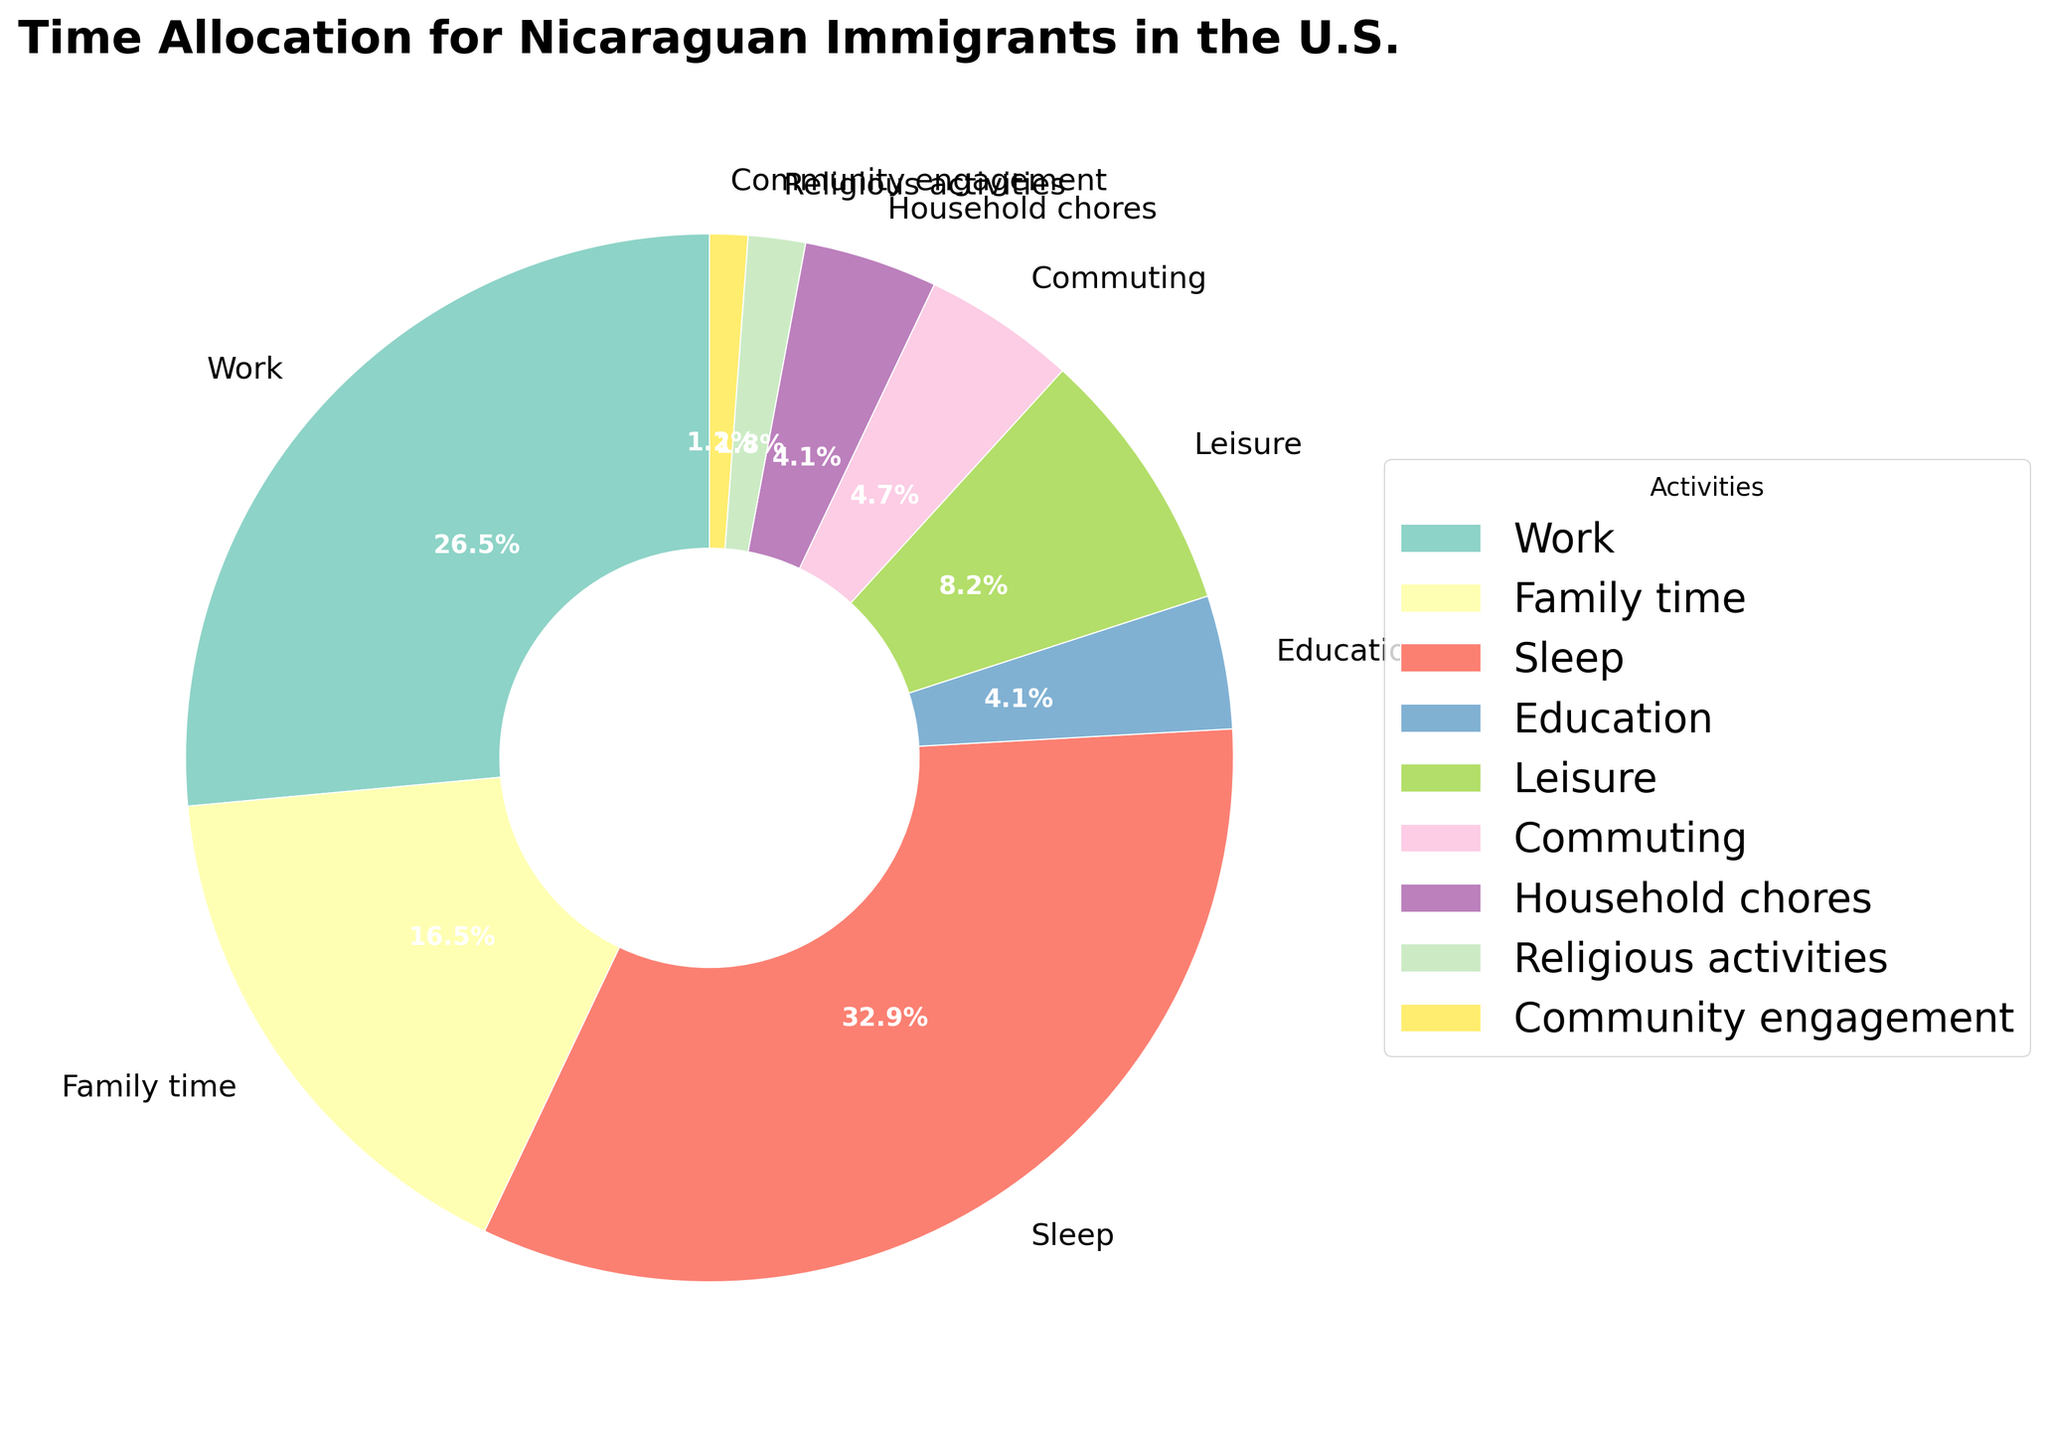What's the most time-consuming activity? The pie chart shows varying percentages for each activity, with the largest segment representing the highest time allocation. Identifying the largest segment of the pie, we see that "Sleep" is the most time-consuming.
Answer: Sleep What is the combined percentage of time spent on education and leisure? To find the combined percentage, sum the individual percentages of Education and Leisure segments. Education is 7/170 * 100 ≈ 4.1%, and Leisure is 14/170 * 100 ≈ 8.2%. Combining these percentages gives 4.1 + 8.2 ≈ 12.3%.
Answer: 12.3% Which two activities have equal time allocation? By comparing the hours per week for each activity on the pie chart, "Education" and "Household chores" both show 7 hours per week.
Answer: Education and Household chores What is the difference in time allocation between work and leisure? Locate the segments representing Work (45 hours) and Leisure (14 hours). The difference is calculated as 45 - 14 = 31 hours.
Answer: 31 hours What proportion of time is allocated to work relative to the total time spent? The percentage of time spent on work is found by the formula: (Hours spent on Work / Total hours) * 100, which is (45/170) * 100 ≈ 26.5%.
Answer: 26.5% Which color represents Community engagement in the pie chart? The visual inspection of the pie chart identifies the specific color linked to Community engagement segment. As the pie chart uses a colormap, Community engagement is color-coded identifiably.
Answer: Step explanation needed (with visual specifics), but the answer is often contextually evident Compare the time spent on family time with commuting. Which one is higher? The pie chart segments for family time and commuting show their respective hours per week. Family time is 28 hours/week, and commuting is 8 hours/week. Thus, family time is higher.
Answer: Family time What is the combined percentage of time spent on religious activities and community engagement? The percentages are calculated individually for Religious activities (3/170 * 100 ≈ 1.8%) and Community engagement (2/170 * 100 ≈ 1.2%). The combined percentage is 1.8 + 1.2 = 3%.
Answer: 3% Is the time allocated to household chores greater than that for religious activities? By comparing the segments, Household chores have 7 hours/week while Religious activities have 3 hours/week, making household chores greater.
Answer: Yes Determine the percentage difference between sleep and family time. Calculate the individual percentages first: Sleep is (56/170) * 100 ≈ 32.9%, and Family time is (28/170) * 100 ≈ 16.5%. The percentage difference is 32.9 - 16.5 ≈ 16.4%.
Answer: 16.4% 